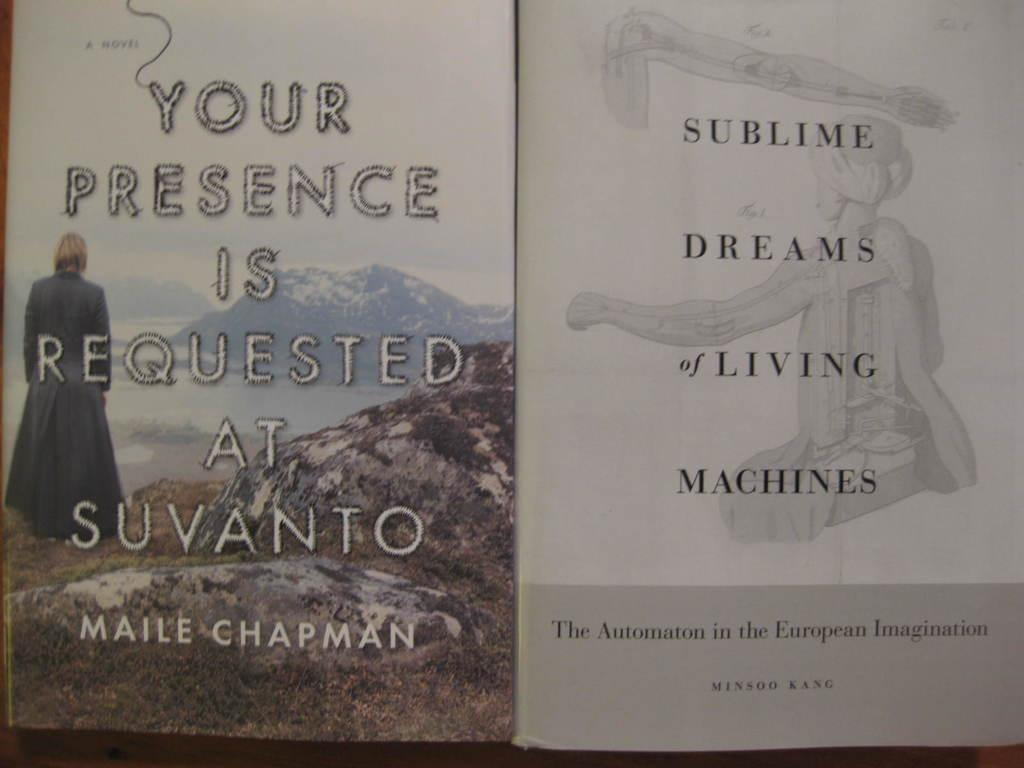<image>
Give a short and clear explanation of the subsequent image. Two books side by side and the left is written by Maile Chapman. 